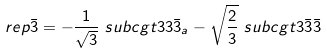<formula> <loc_0><loc_0><loc_500><loc_500>\ r e p { \bar { 3 } } & = - \frac { 1 } { \sqrt { 3 } } \ s u b c g t { 3 } { 3 } { \bar { 3 } _ { a } } - \sqrt { \frac { 2 } { 3 } } \ s u b c g t { 3 } { \bar { 3 } } { \bar { 3 } }</formula> 